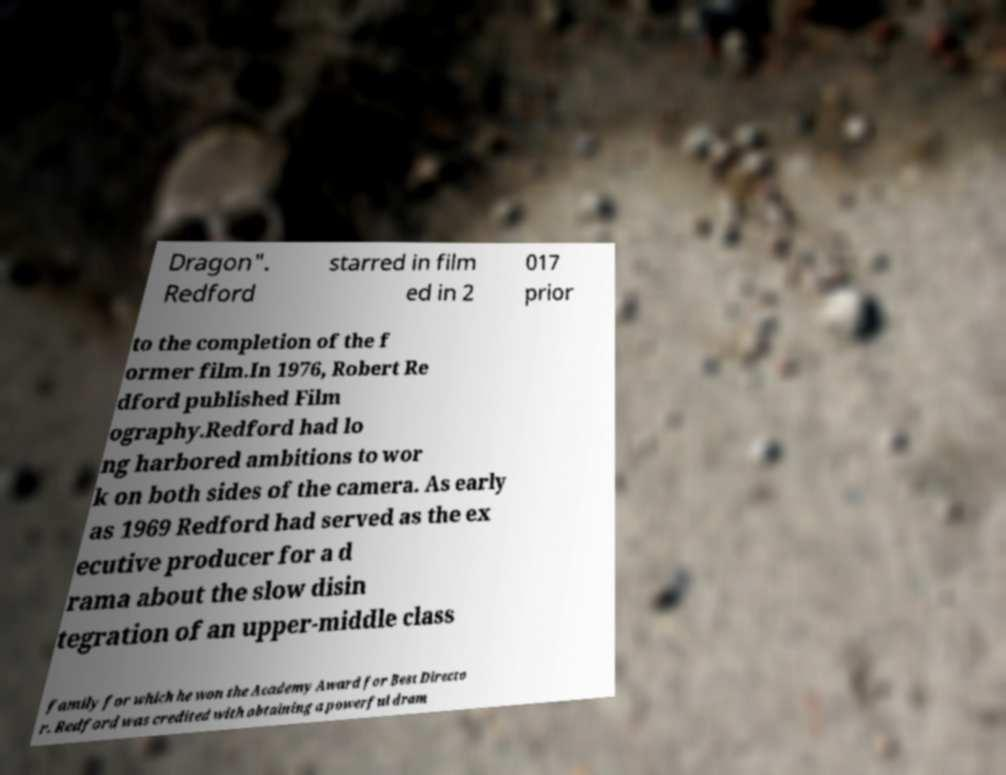Can you read and provide the text displayed in the image?This photo seems to have some interesting text. Can you extract and type it out for me? Dragon". Redford starred in film ed in 2 017 prior to the completion of the f ormer film.In 1976, Robert Re dford published Film ography.Redford had lo ng harbored ambitions to wor k on both sides of the camera. As early as 1969 Redford had served as the ex ecutive producer for a d rama about the slow disin tegration of an upper-middle class family for which he won the Academy Award for Best Directo r. Redford was credited with obtaining a powerful dram 